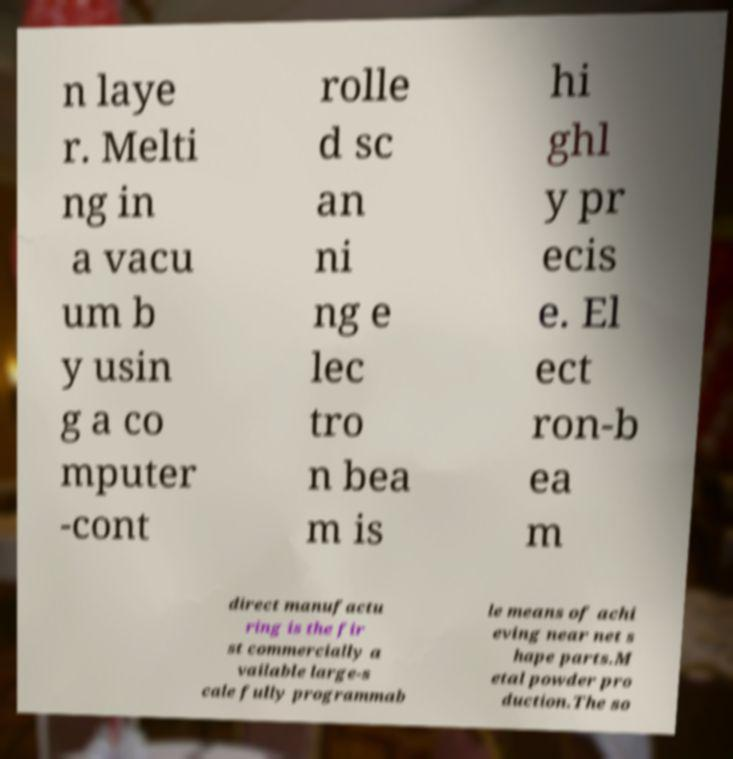Please identify and transcribe the text found in this image. n laye r. Melti ng in a vacu um b y usin g a co mputer -cont rolle d sc an ni ng e lec tro n bea m is hi ghl y pr ecis e. El ect ron-b ea m direct manufactu ring is the fir st commercially a vailable large-s cale fully programmab le means of achi eving near net s hape parts.M etal powder pro duction.The so 